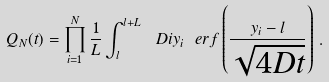Convert formula to latex. <formula><loc_0><loc_0><loc_500><loc_500>Q _ { N } ( t ) = \prod _ { i = 1 } ^ { N } \frac { 1 } { L } \int _ { l } ^ { l + L } \ D i { y _ { i } } \ e r f \left ( \frac { y _ { i } - l } { \sqrt { 4 D t } } \right ) \, .</formula> 